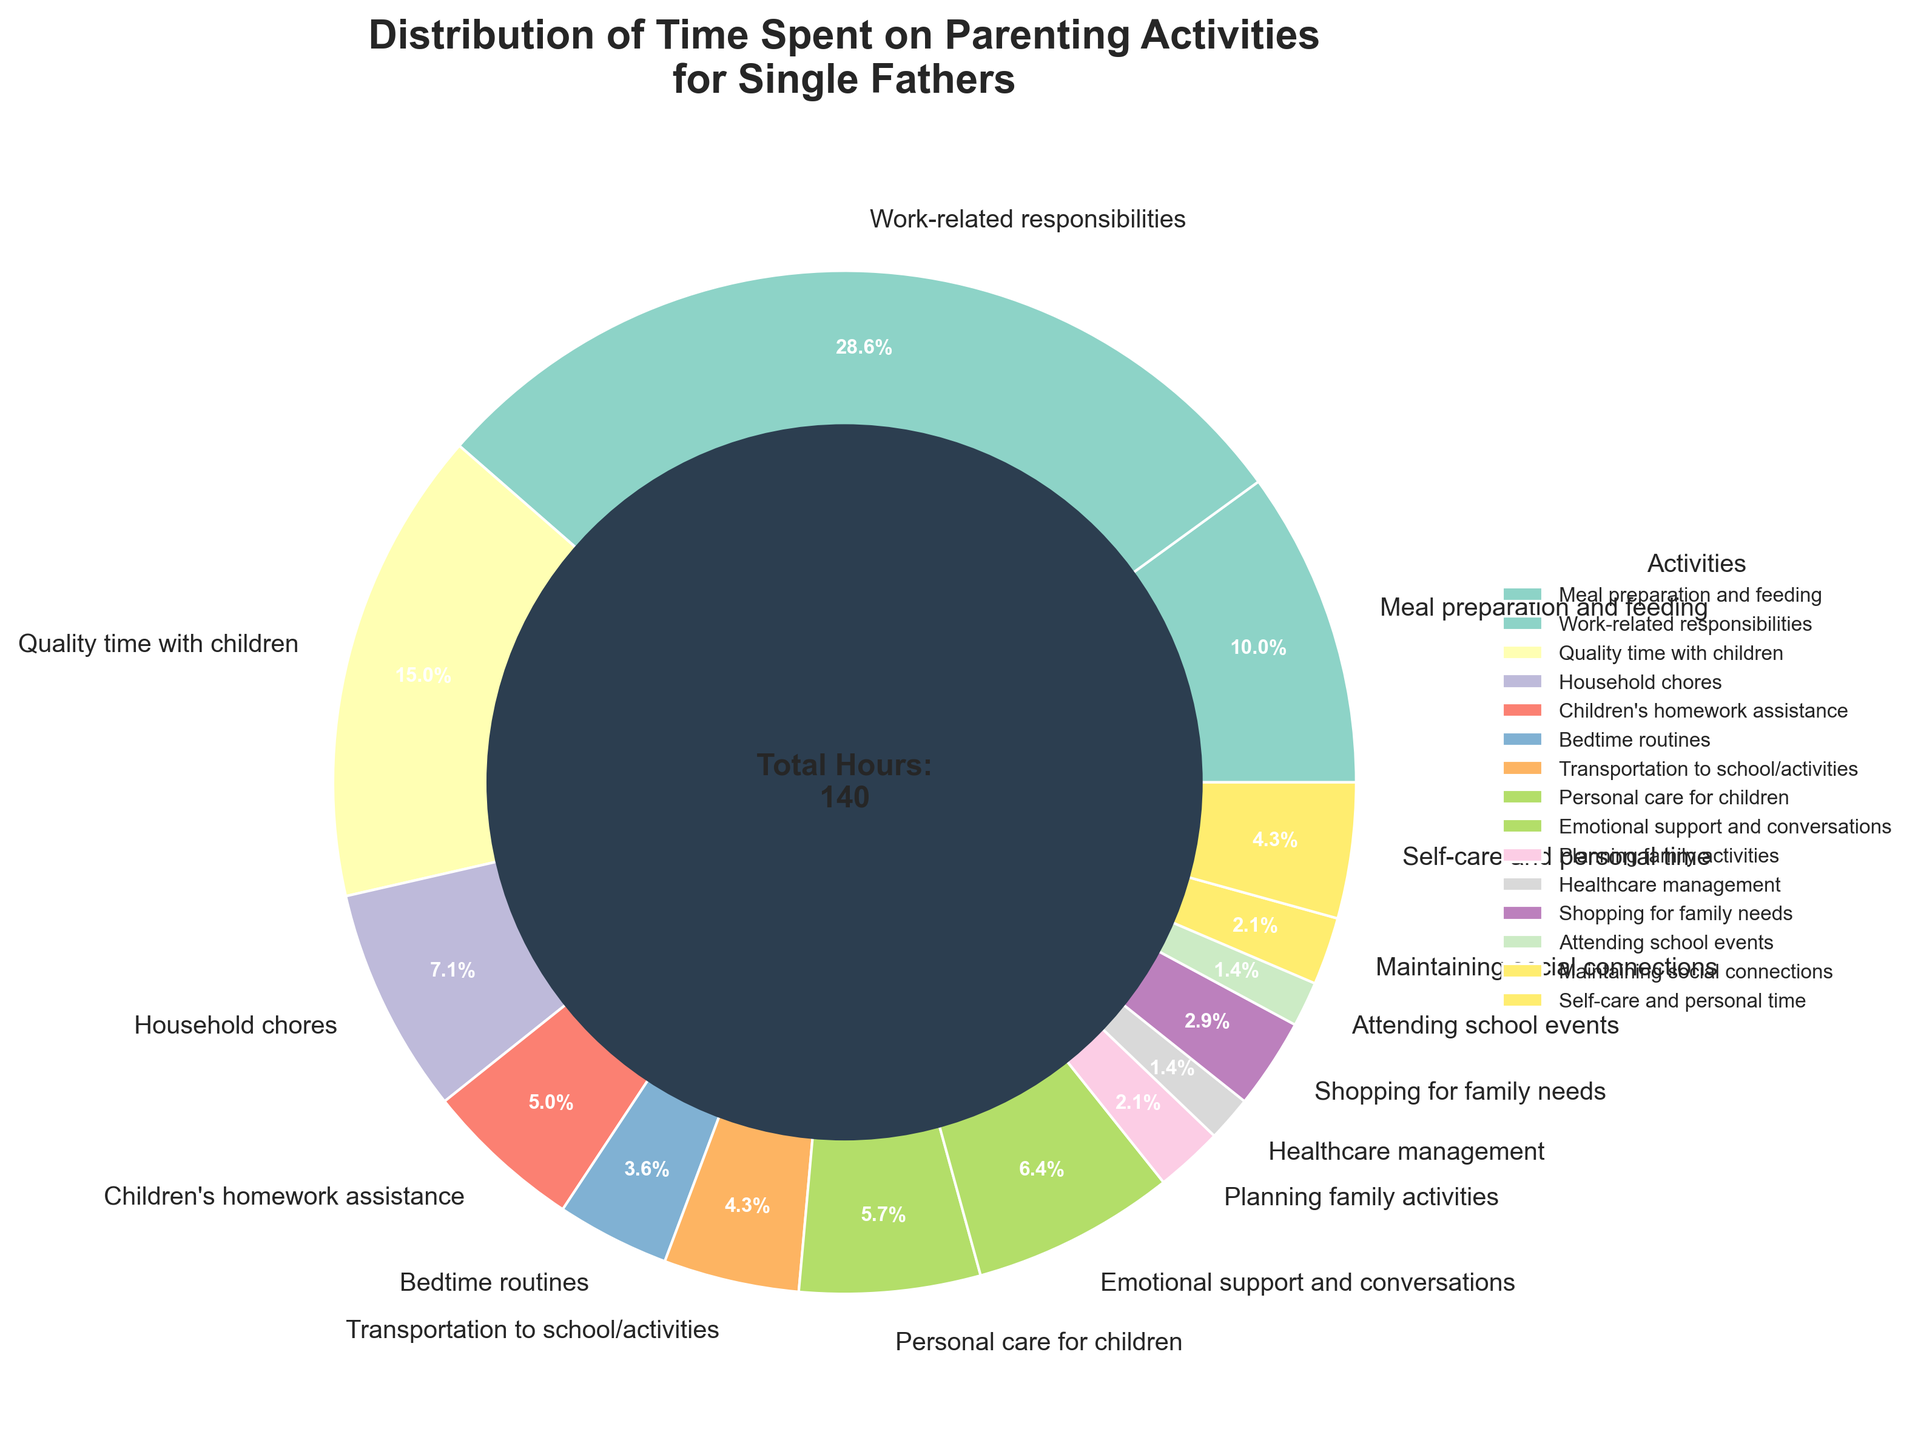What percentage of time is spent on quality time with children and emotional support combined? To find the combined percentage for quality time with children and emotional support, sum their hours (21 for quality time + 9 for emotional support = 30) and divide by the total hours (total is 140), then multiply by 100. (30 / 140) * 100 = 21.4%
Answer: 21.4% Which activity occupies less time, healthcare management or planning family activities? To determine which activity occupies less time, compare their hours. Healthcare management has 2 hours, and planning family activities has 3 hours.
Answer: Healthcare management Is more time spent on transportation to school/activities or shopping for family needs? To determine which activity occupies more time, compare their hours. Transportation to school/activities has 6 hours, and shopping for family needs has 4 hours.
Answer: Transportation to school/activities How much time is allocated to meal preparation and feeding as a percentage of the total time? To find the percentage of time allocated to meal preparation and feeding, divide the hours for this activity (14) by the total hours (140) and multiply by 100. (14 / 140) * 100 = 10%
Answer: 10% Do work-related responsibilities take up more than half of the total time? To find out if work-related responsibilities take up more than half of the total time, check if their hours (40) are more than half of the total hours (140). 40 is less than 70.
Answer: No What is the time difference between personal care for children and assisting with children's homework? To find the time difference, subtract the hours spent assisting with children's homework (7) from the hours spent on personal care for children (8). 8 - 7 = 1 hour
Answer: 1 hour Which activity has the smallest percentage share? To find the activity with the smallest percentage share, look for the activity with the fewest hours. Healthcare management and attending school events have the lowest at 2 hours each.
Answer: Healthcare management and attending school events Is more time spent on emotional support and conversations or self-care and personal time? Compare the hours spent on emotional support and conversations (9) against self-care and personal time (6).
Answer: Emotional support and conversations What is the combined percentage of time spent on household chores and personal care for children? To find the combined percentage, sum the hours for household chores (10) and personal care for children (8), then divide by the total hours (140) and multiply by 100. (10 + 8) / 140 * 100 = 12.9%
Answer: 12.9% How much time is spent on shopping for family needs as a proportion of the total time? To find the proportion, divide the hours for shopping (4) by the total hours (140). 4 / 140 = 0.0286, or approximately 2.9%
Answer: 2.9% 